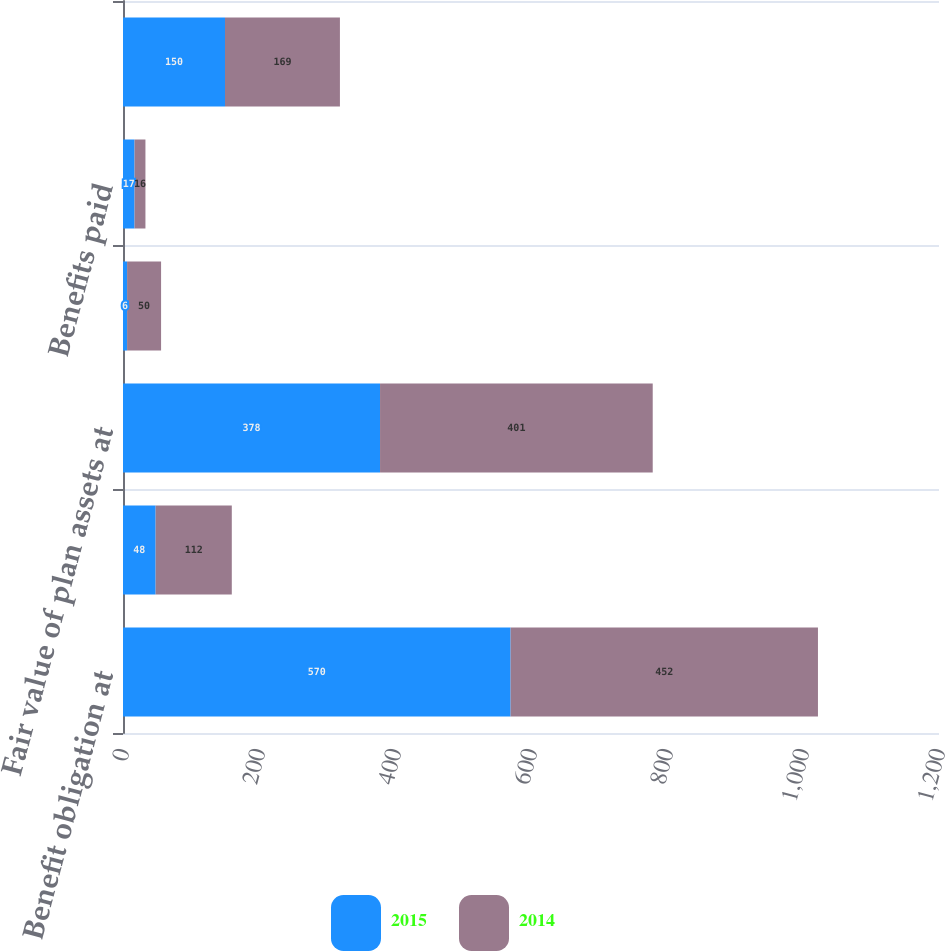Convert chart. <chart><loc_0><loc_0><loc_500><loc_500><stacked_bar_chart><ecel><fcel>Benefit obligation at<fcel>Employee contributions<fcel>Fair value of plan assets at<fcel>Actual return on plan assets<fcel>Benefits paid<fcel>Unfunded status (recorded in<nl><fcel>2015<fcel>570<fcel>48<fcel>378<fcel>6<fcel>17<fcel>150<nl><fcel>2014<fcel>452<fcel>112<fcel>401<fcel>50<fcel>16<fcel>169<nl></chart> 